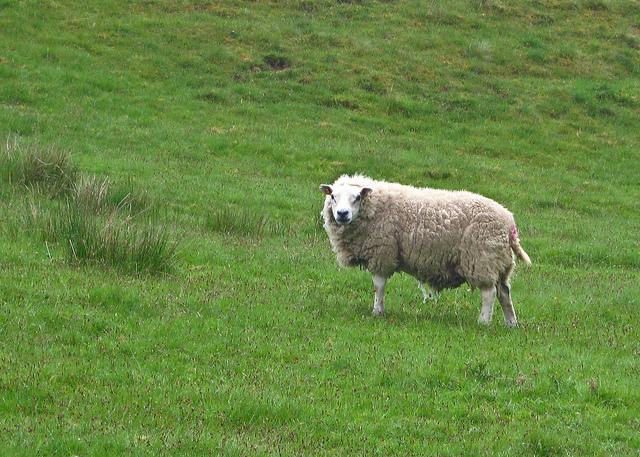What do you think the sheep is thinking?
Answer briefly. Go away. Is the animal facing left or right?
Be succinct. Left. Is the animal looking at the camera?
Short answer required. Yes. 